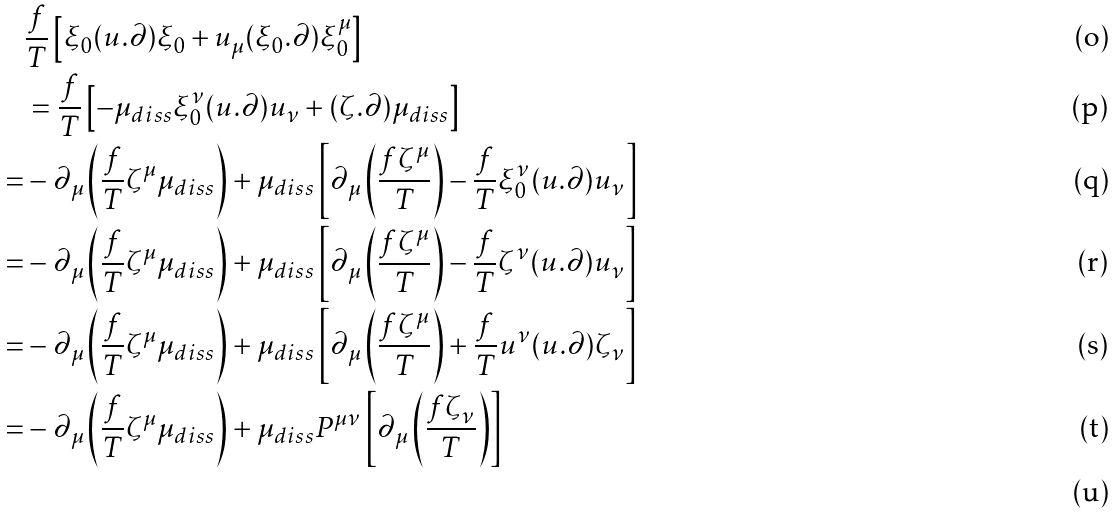<formula> <loc_0><loc_0><loc_500><loc_500>& \frac { f } { T } \left [ \xi _ { 0 } ( u . \partial ) \xi _ { 0 } + u _ { \mu } ( \xi _ { 0 } . \partial ) \xi ^ { \mu } _ { 0 } \right ] \\ & = \frac { f } { T } \left [ - \mu _ { d i s s } \xi _ { 0 } ^ { \nu } ( u . \partial ) u _ { \nu } + ( \zeta . \partial ) \mu _ { d i s s } \right ] \\ = & - \partial _ { \mu } \left ( \frac { f } { T } \zeta ^ { \mu } \mu _ { d i s s } \right ) + \mu _ { d i s s } \left [ \partial _ { \mu } \left ( \frac { f \zeta ^ { \mu } } { T } \right ) - \frac { f } { T } \xi _ { 0 } ^ { \nu } ( u . \partial ) u _ { \nu } \right ] \\ = & - \partial _ { \mu } \left ( \frac { f } { T } \zeta ^ { \mu } \mu _ { d i s s } \right ) + \mu _ { d i s s } \left [ \partial _ { \mu } \left ( \frac { f \zeta ^ { \mu } } { T } \right ) - \frac { f } { T } \zeta ^ { \nu } ( u . \partial ) u _ { \nu } \right ] \\ = & - \partial _ { \mu } \left ( \frac { f } { T } \zeta ^ { \mu } \mu _ { d i s s } \right ) + \mu _ { d i s s } \left [ \partial _ { \mu } \left ( \frac { f \zeta ^ { \mu } } { T } \right ) + \frac { f } { T } u ^ { \nu } ( u . \partial ) \zeta _ { \nu } \right ] \\ = & - \partial _ { \mu } \left ( \frac { f } { T } \zeta ^ { \mu } \mu _ { d i s s } \right ) + \mu _ { d i s s } P ^ { \mu \nu } \left [ \partial _ { \mu } \left ( \frac { f \zeta _ { \nu } } { T } \right ) \right ] \\</formula> 